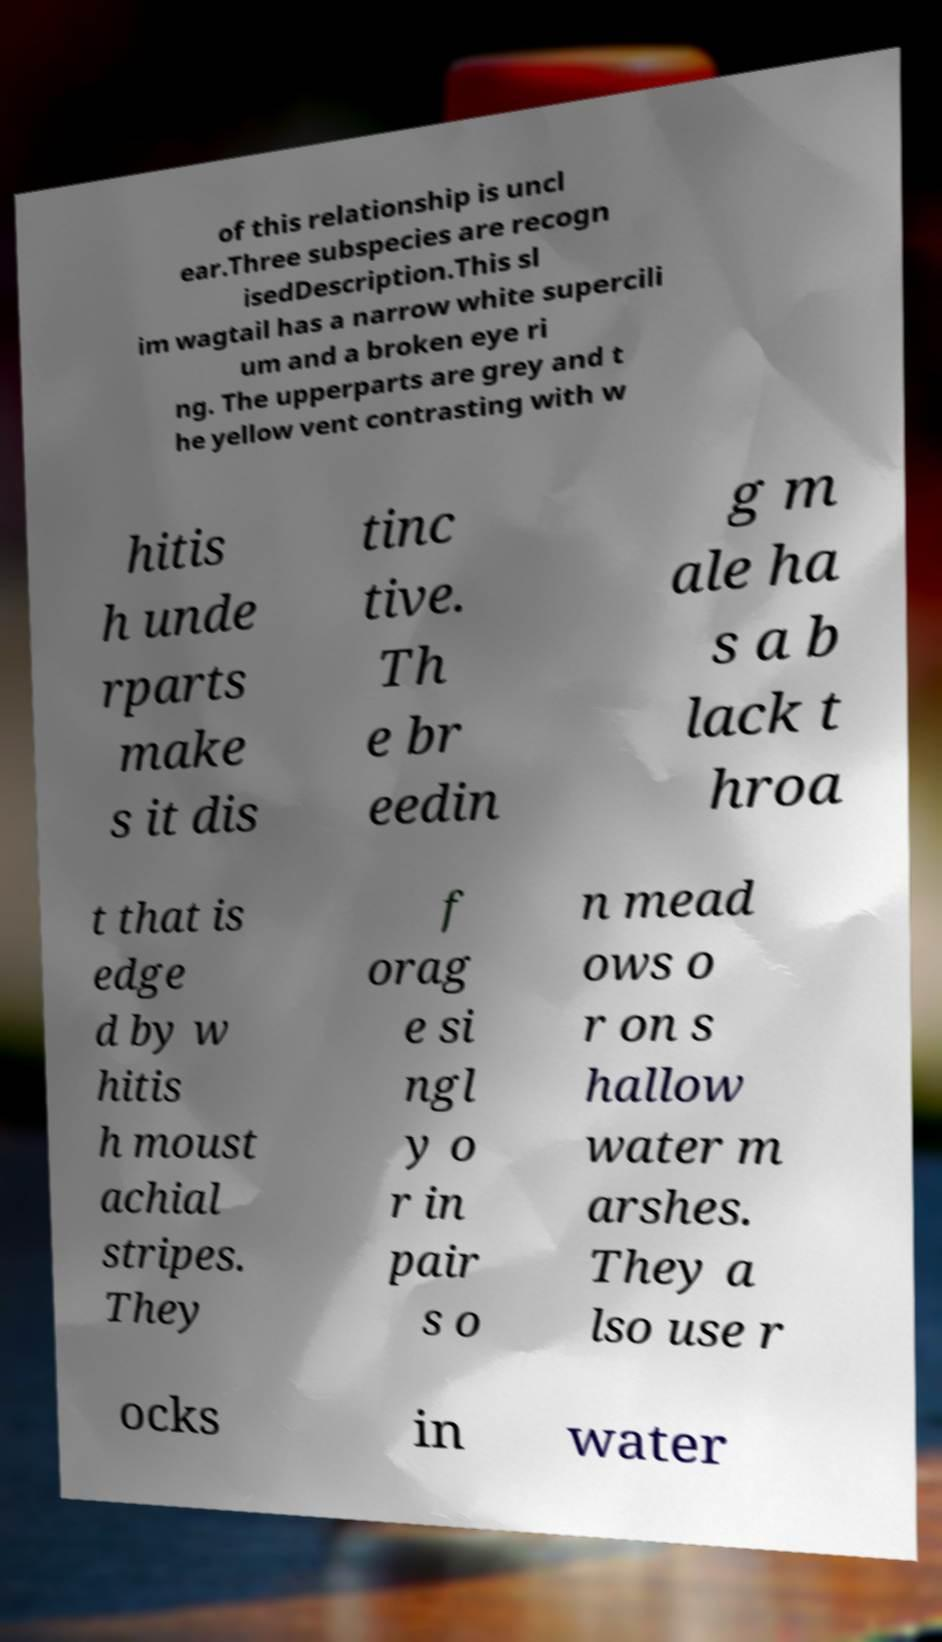Can you accurately transcribe the text from the provided image for me? of this relationship is uncl ear.Three subspecies are recogn isedDescription.This sl im wagtail has a narrow white supercili um and a broken eye ri ng. The upperparts are grey and t he yellow vent contrasting with w hitis h unde rparts make s it dis tinc tive. Th e br eedin g m ale ha s a b lack t hroa t that is edge d by w hitis h moust achial stripes. They f orag e si ngl y o r in pair s o n mead ows o r on s hallow water m arshes. They a lso use r ocks in water 